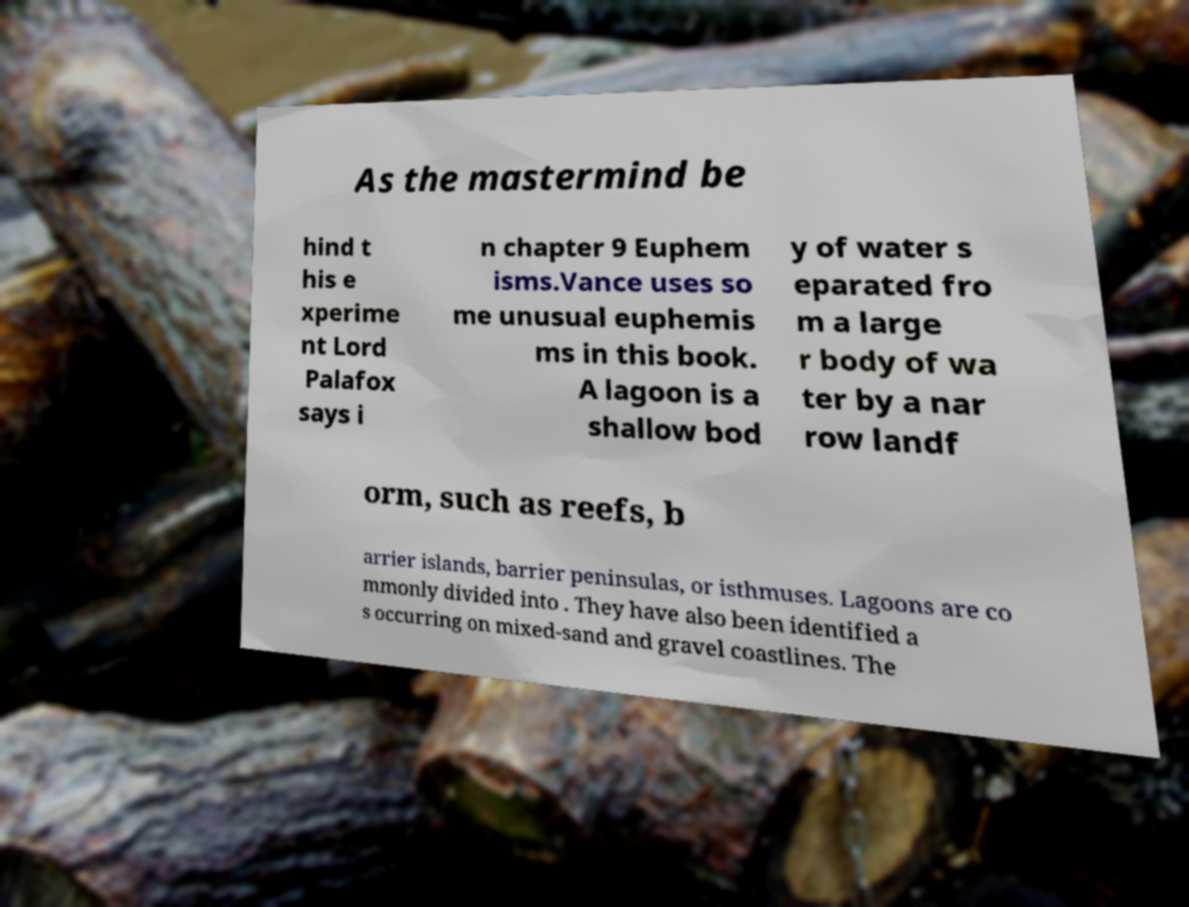Can you read and provide the text displayed in the image?This photo seems to have some interesting text. Can you extract and type it out for me? As the mastermind be hind t his e xperime nt Lord Palafox says i n chapter 9 Euphem isms.Vance uses so me unusual euphemis ms in this book. A lagoon is a shallow bod y of water s eparated fro m a large r body of wa ter by a nar row landf orm, such as reefs, b arrier islands, barrier peninsulas, or isthmuses. Lagoons are co mmonly divided into . They have also been identified a s occurring on mixed-sand and gravel coastlines. The 